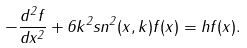Convert formula to latex. <formula><loc_0><loc_0><loc_500><loc_500>- \frac { d ^ { 2 } f } { d x ^ { 2 } } + 6 k ^ { 2 } s n ^ { 2 } ( x , k ) f ( x ) = h f ( x ) .</formula> 